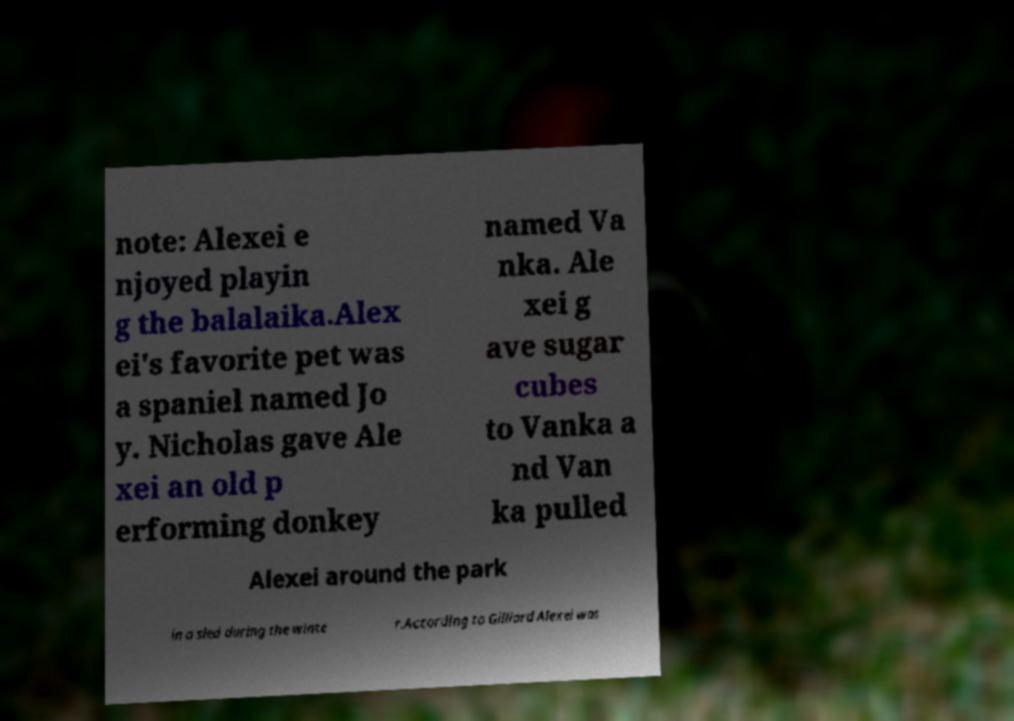Could you assist in decoding the text presented in this image and type it out clearly? note: Alexei e njoyed playin g the balalaika.Alex ei's favorite pet was a spaniel named Jo y. Nicholas gave Ale xei an old p erforming donkey named Va nka. Ale xei g ave sugar cubes to Vanka a nd Van ka pulled Alexei around the park in a sled during the winte r.According to Gilliard Alexei was 